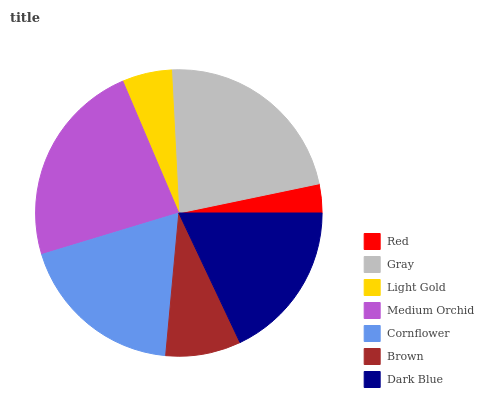Is Red the minimum?
Answer yes or no. Yes. Is Medium Orchid the maximum?
Answer yes or no. Yes. Is Gray the minimum?
Answer yes or no. No. Is Gray the maximum?
Answer yes or no. No. Is Gray greater than Red?
Answer yes or no. Yes. Is Red less than Gray?
Answer yes or no. Yes. Is Red greater than Gray?
Answer yes or no. No. Is Gray less than Red?
Answer yes or no. No. Is Dark Blue the high median?
Answer yes or no. Yes. Is Dark Blue the low median?
Answer yes or no. Yes. Is Gray the high median?
Answer yes or no. No. Is Light Gold the low median?
Answer yes or no. No. 